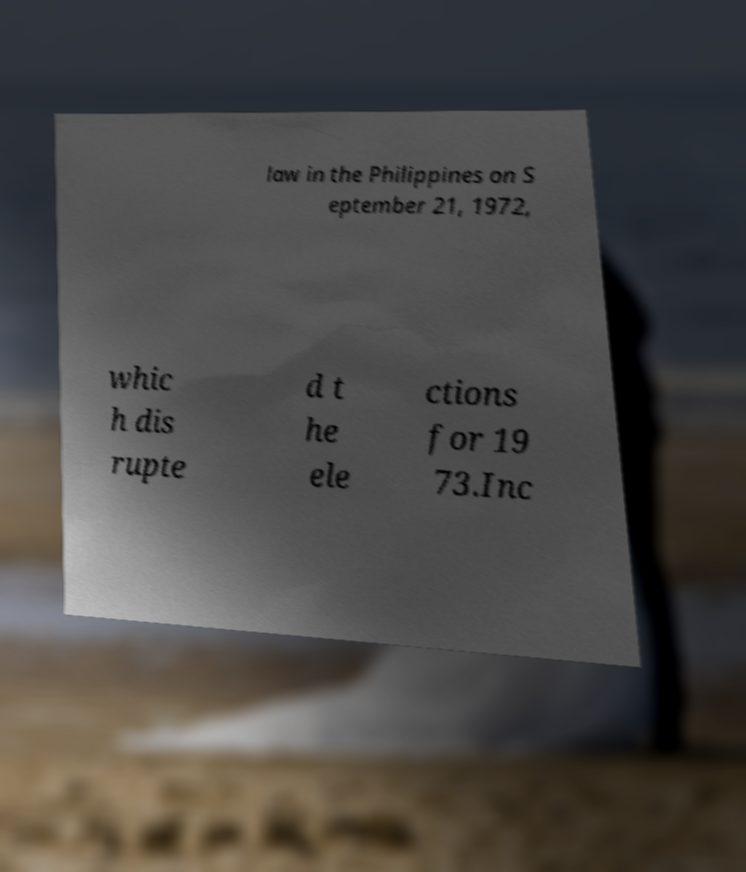I need the written content from this picture converted into text. Can you do that? law in the Philippines on S eptember 21, 1972, whic h dis rupte d t he ele ctions for 19 73.Inc 